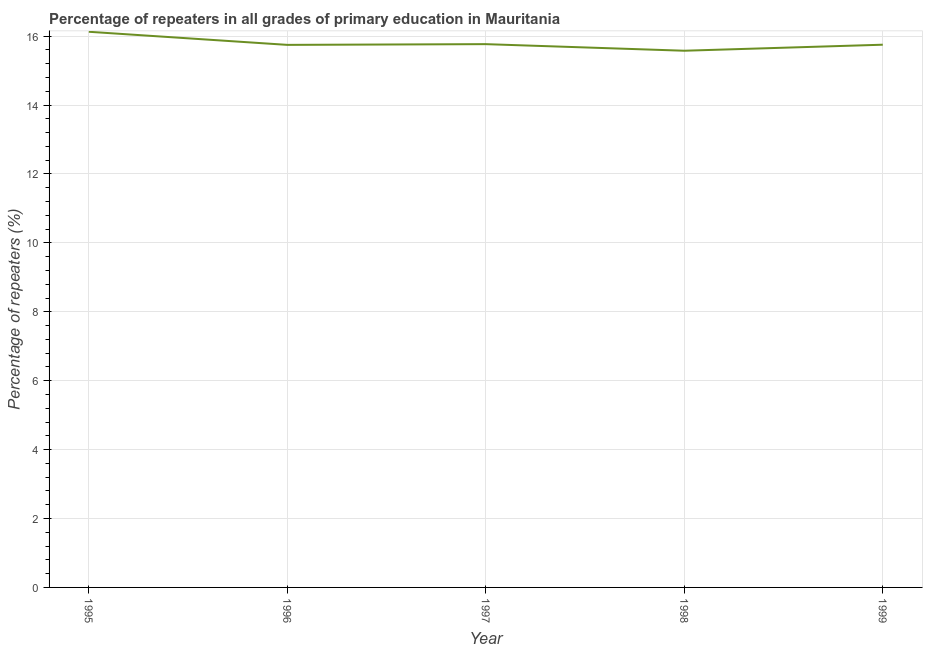What is the percentage of repeaters in primary education in 1996?
Make the answer very short. 15.75. Across all years, what is the maximum percentage of repeaters in primary education?
Give a very brief answer. 16.13. Across all years, what is the minimum percentage of repeaters in primary education?
Ensure brevity in your answer.  15.58. In which year was the percentage of repeaters in primary education maximum?
Provide a succinct answer. 1995. What is the sum of the percentage of repeaters in primary education?
Make the answer very short. 78.97. What is the difference between the percentage of repeaters in primary education in 1998 and 1999?
Offer a terse response. -0.18. What is the average percentage of repeaters in primary education per year?
Keep it short and to the point. 15.79. What is the median percentage of repeaters in primary education?
Your response must be concise. 15.75. What is the ratio of the percentage of repeaters in primary education in 1995 to that in 1996?
Your response must be concise. 1.02. Is the percentage of repeaters in primary education in 1995 less than that in 1996?
Ensure brevity in your answer.  No. Is the difference between the percentage of repeaters in primary education in 1996 and 1997 greater than the difference between any two years?
Provide a short and direct response. No. What is the difference between the highest and the second highest percentage of repeaters in primary education?
Make the answer very short. 0.36. What is the difference between the highest and the lowest percentage of repeaters in primary education?
Keep it short and to the point. 0.55. Does the percentage of repeaters in primary education monotonically increase over the years?
Keep it short and to the point. No. How many lines are there?
Give a very brief answer. 1. How many years are there in the graph?
Offer a very short reply. 5. What is the title of the graph?
Give a very brief answer. Percentage of repeaters in all grades of primary education in Mauritania. What is the label or title of the X-axis?
Provide a short and direct response. Year. What is the label or title of the Y-axis?
Offer a terse response. Percentage of repeaters (%). What is the Percentage of repeaters (%) in 1995?
Keep it short and to the point. 16.13. What is the Percentage of repeaters (%) of 1996?
Give a very brief answer. 15.75. What is the Percentage of repeaters (%) of 1997?
Keep it short and to the point. 15.77. What is the Percentage of repeaters (%) in 1998?
Keep it short and to the point. 15.58. What is the Percentage of repeaters (%) in 1999?
Offer a very short reply. 15.75. What is the difference between the Percentage of repeaters (%) in 1995 and 1996?
Offer a terse response. 0.38. What is the difference between the Percentage of repeaters (%) in 1995 and 1997?
Give a very brief answer. 0.36. What is the difference between the Percentage of repeaters (%) in 1995 and 1998?
Offer a terse response. 0.55. What is the difference between the Percentage of repeaters (%) in 1995 and 1999?
Offer a very short reply. 0.38. What is the difference between the Percentage of repeaters (%) in 1996 and 1997?
Offer a terse response. -0.02. What is the difference between the Percentage of repeaters (%) in 1996 and 1998?
Offer a terse response. 0.17. What is the difference between the Percentage of repeaters (%) in 1996 and 1999?
Your answer should be compact. -0.01. What is the difference between the Percentage of repeaters (%) in 1997 and 1998?
Make the answer very short. 0.19. What is the difference between the Percentage of repeaters (%) in 1997 and 1999?
Offer a terse response. 0.02. What is the difference between the Percentage of repeaters (%) in 1998 and 1999?
Your answer should be very brief. -0.18. What is the ratio of the Percentage of repeaters (%) in 1995 to that in 1997?
Give a very brief answer. 1.02. What is the ratio of the Percentage of repeaters (%) in 1995 to that in 1998?
Keep it short and to the point. 1.03. What is the ratio of the Percentage of repeaters (%) in 1996 to that in 1998?
Offer a very short reply. 1.01. What is the ratio of the Percentage of repeaters (%) in 1997 to that in 1999?
Provide a short and direct response. 1. 